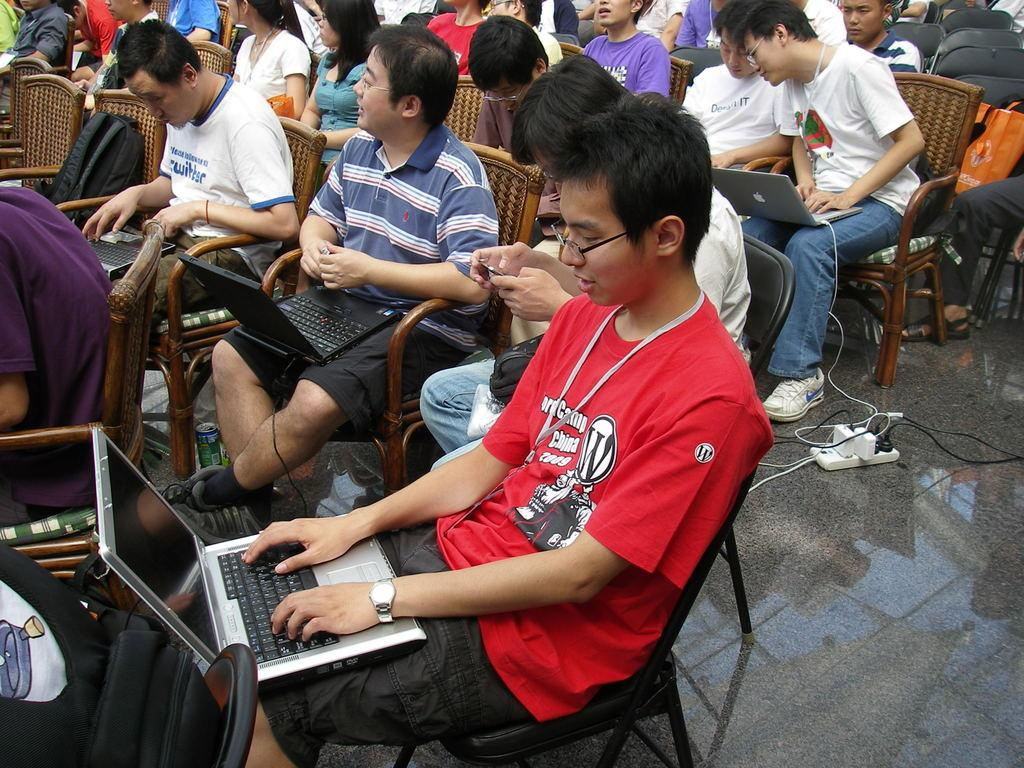What are the people in the image doing? The people in the image are seated on chairs. What are some of the people using while seated? Some of the people are working on laptops. What can be found on the floor in the image? There is an extension switchboard on the floor in the image. Can you tell me how many basketballs are visible in the image? There are no basketballs present in the image. Is there a ball being used by any of the people in the image? There is no ball being used by any of the people in the image. 